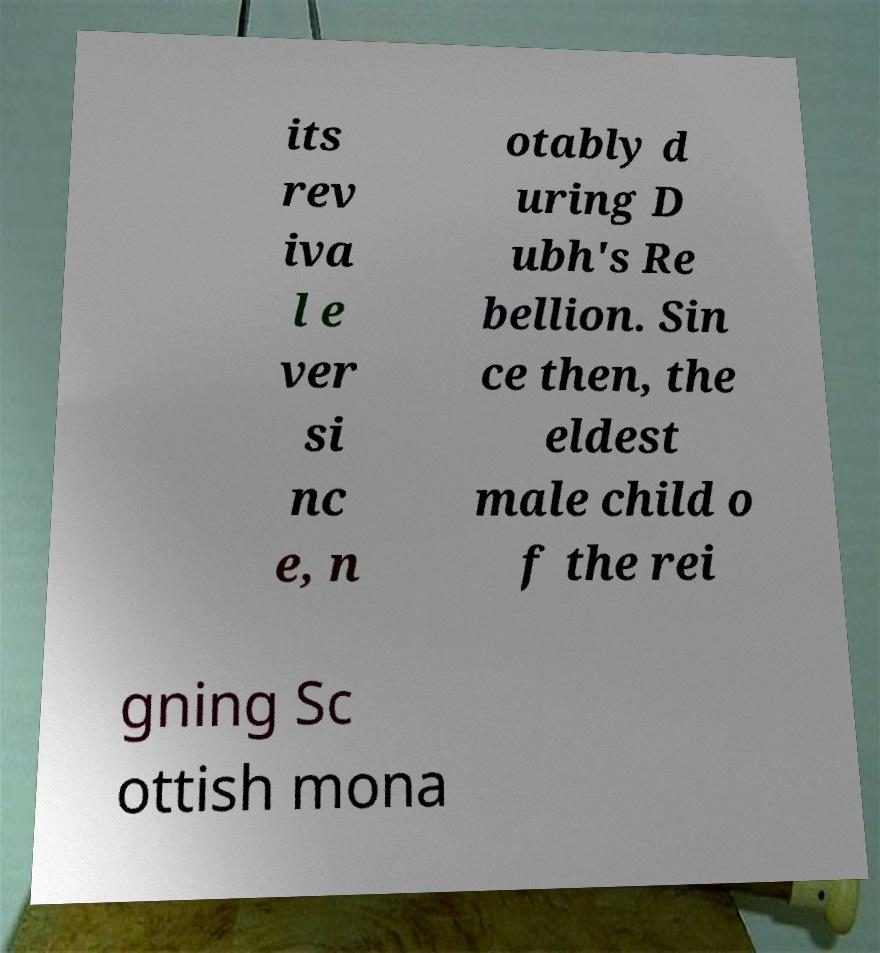Could you assist in decoding the text presented in this image and type it out clearly? its rev iva l e ver si nc e, n otably d uring D ubh's Re bellion. Sin ce then, the eldest male child o f the rei gning Sc ottish mona 